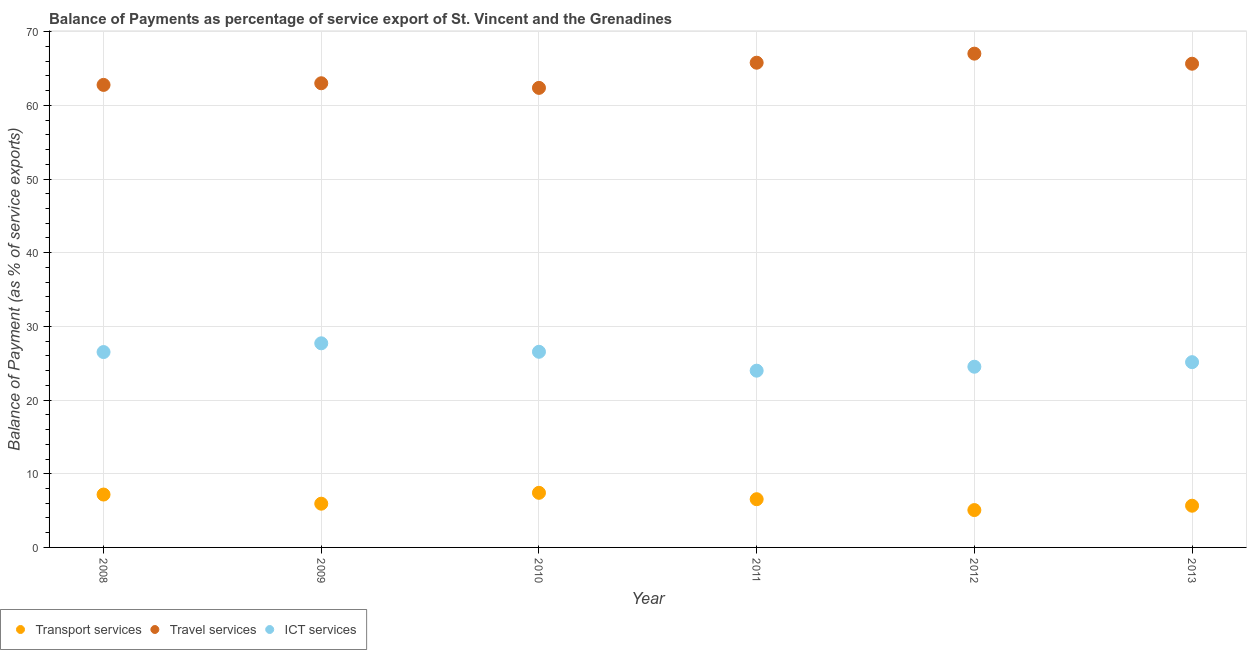What is the balance of payment of ict services in 2011?
Provide a short and direct response. 23.99. Across all years, what is the maximum balance of payment of transport services?
Your answer should be very brief. 7.41. Across all years, what is the minimum balance of payment of ict services?
Ensure brevity in your answer.  23.99. In which year was the balance of payment of transport services minimum?
Make the answer very short. 2012. What is the total balance of payment of travel services in the graph?
Offer a terse response. 386.58. What is the difference between the balance of payment of transport services in 2012 and that in 2013?
Your answer should be very brief. -0.59. What is the difference between the balance of payment of transport services in 2010 and the balance of payment of ict services in 2009?
Keep it short and to the point. -20.29. What is the average balance of payment of ict services per year?
Your answer should be compact. 25.74. In the year 2011, what is the difference between the balance of payment of transport services and balance of payment of ict services?
Give a very brief answer. -17.44. What is the ratio of the balance of payment of ict services in 2009 to that in 2013?
Provide a succinct answer. 1.1. Is the difference between the balance of payment of ict services in 2008 and 2010 greater than the difference between the balance of payment of transport services in 2008 and 2010?
Ensure brevity in your answer.  Yes. What is the difference between the highest and the second highest balance of payment of ict services?
Offer a terse response. 1.15. What is the difference between the highest and the lowest balance of payment of travel services?
Provide a succinct answer. 4.65. In how many years, is the balance of payment of travel services greater than the average balance of payment of travel services taken over all years?
Keep it short and to the point. 3. Is it the case that in every year, the sum of the balance of payment of transport services and balance of payment of travel services is greater than the balance of payment of ict services?
Your answer should be compact. Yes. Does the balance of payment of travel services monotonically increase over the years?
Offer a terse response. No. Is the balance of payment of ict services strictly greater than the balance of payment of transport services over the years?
Give a very brief answer. Yes. Is the balance of payment of travel services strictly less than the balance of payment of transport services over the years?
Ensure brevity in your answer.  No. How many years are there in the graph?
Your answer should be compact. 6. Where does the legend appear in the graph?
Your response must be concise. Bottom left. How many legend labels are there?
Give a very brief answer. 3. How are the legend labels stacked?
Make the answer very short. Horizontal. What is the title of the graph?
Your answer should be very brief. Balance of Payments as percentage of service export of St. Vincent and the Grenadines. Does "Ages 0-14" appear as one of the legend labels in the graph?
Make the answer very short. No. What is the label or title of the X-axis?
Give a very brief answer. Year. What is the label or title of the Y-axis?
Make the answer very short. Balance of Payment (as % of service exports). What is the Balance of Payment (as % of service exports) of Transport services in 2008?
Your answer should be very brief. 7.18. What is the Balance of Payment (as % of service exports) in Travel services in 2008?
Your answer should be compact. 62.77. What is the Balance of Payment (as % of service exports) in ICT services in 2008?
Give a very brief answer. 26.52. What is the Balance of Payment (as % of service exports) in Transport services in 2009?
Provide a succinct answer. 5.94. What is the Balance of Payment (as % of service exports) in Travel services in 2009?
Your answer should be compact. 63. What is the Balance of Payment (as % of service exports) of ICT services in 2009?
Provide a succinct answer. 27.7. What is the Balance of Payment (as % of service exports) in Transport services in 2010?
Make the answer very short. 7.41. What is the Balance of Payment (as % of service exports) of Travel services in 2010?
Your answer should be compact. 62.37. What is the Balance of Payment (as % of service exports) in ICT services in 2010?
Your answer should be compact. 26.55. What is the Balance of Payment (as % of service exports) of Transport services in 2011?
Offer a very short reply. 6.54. What is the Balance of Payment (as % of service exports) of Travel services in 2011?
Give a very brief answer. 65.78. What is the Balance of Payment (as % of service exports) of ICT services in 2011?
Provide a succinct answer. 23.99. What is the Balance of Payment (as % of service exports) of Transport services in 2012?
Your answer should be very brief. 5.07. What is the Balance of Payment (as % of service exports) of Travel services in 2012?
Your answer should be very brief. 67.01. What is the Balance of Payment (as % of service exports) in ICT services in 2012?
Offer a terse response. 24.52. What is the Balance of Payment (as % of service exports) of Transport services in 2013?
Provide a short and direct response. 5.66. What is the Balance of Payment (as % of service exports) in Travel services in 2013?
Offer a very short reply. 65.65. What is the Balance of Payment (as % of service exports) in ICT services in 2013?
Provide a succinct answer. 25.14. Across all years, what is the maximum Balance of Payment (as % of service exports) in Transport services?
Keep it short and to the point. 7.41. Across all years, what is the maximum Balance of Payment (as % of service exports) of Travel services?
Ensure brevity in your answer.  67.01. Across all years, what is the maximum Balance of Payment (as % of service exports) in ICT services?
Provide a succinct answer. 27.7. Across all years, what is the minimum Balance of Payment (as % of service exports) in Transport services?
Your answer should be very brief. 5.07. Across all years, what is the minimum Balance of Payment (as % of service exports) in Travel services?
Offer a terse response. 62.37. Across all years, what is the minimum Balance of Payment (as % of service exports) in ICT services?
Your response must be concise. 23.99. What is the total Balance of Payment (as % of service exports) in Transport services in the graph?
Offer a very short reply. 37.8. What is the total Balance of Payment (as % of service exports) of Travel services in the graph?
Offer a terse response. 386.58. What is the total Balance of Payment (as % of service exports) of ICT services in the graph?
Your response must be concise. 154.42. What is the difference between the Balance of Payment (as % of service exports) in Transport services in 2008 and that in 2009?
Your response must be concise. 1.24. What is the difference between the Balance of Payment (as % of service exports) of Travel services in 2008 and that in 2009?
Your answer should be compact. -0.22. What is the difference between the Balance of Payment (as % of service exports) in ICT services in 2008 and that in 2009?
Provide a short and direct response. -1.19. What is the difference between the Balance of Payment (as % of service exports) in Transport services in 2008 and that in 2010?
Make the answer very short. -0.23. What is the difference between the Balance of Payment (as % of service exports) of Travel services in 2008 and that in 2010?
Ensure brevity in your answer.  0.4. What is the difference between the Balance of Payment (as % of service exports) in ICT services in 2008 and that in 2010?
Provide a succinct answer. -0.04. What is the difference between the Balance of Payment (as % of service exports) in Transport services in 2008 and that in 2011?
Provide a short and direct response. 0.63. What is the difference between the Balance of Payment (as % of service exports) of Travel services in 2008 and that in 2011?
Your answer should be compact. -3.01. What is the difference between the Balance of Payment (as % of service exports) in ICT services in 2008 and that in 2011?
Give a very brief answer. 2.53. What is the difference between the Balance of Payment (as % of service exports) of Transport services in 2008 and that in 2012?
Make the answer very short. 2.11. What is the difference between the Balance of Payment (as % of service exports) in Travel services in 2008 and that in 2012?
Your response must be concise. -4.24. What is the difference between the Balance of Payment (as % of service exports) of ICT services in 2008 and that in 2012?
Provide a succinct answer. 1.99. What is the difference between the Balance of Payment (as % of service exports) in Transport services in 2008 and that in 2013?
Offer a terse response. 1.52. What is the difference between the Balance of Payment (as % of service exports) of Travel services in 2008 and that in 2013?
Ensure brevity in your answer.  -2.87. What is the difference between the Balance of Payment (as % of service exports) of ICT services in 2008 and that in 2013?
Ensure brevity in your answer.  1.37. What is the difference between the Balance of Payment (as % of service exports) of Transport services in 2009 and that in 2010?
Your response must be concise. -1.48. What is the difference between the Balance of Payment (as % of service exports) of Travel services in 2009 and that in 2010?
Your answer should be very brief. 0.63. What is the difference between the Balance of Payment (as % of service exports) in ICT services in 2009 and that in 2010?
Make the answer very short. 1.15. What is the difference between the Balance of Payment (as % of service exports) of Transport services in 2009 and that in 2011?
Your response must be concise. -0.61. What is the difference between the Balance of Payment (as % of service exports) of Travel services in 2009 and that in 2011?
Provide a succinct answer. -2.79. What is the difference between the Balance of Payment (as % of service exports) in ICT services in 2009 and that in 2011?
Provide a succinct answer. 3.71. What is the difference between the Balance of Payment (as % of service exports) of Transport services in 2009 and that in 2012?
Provide a succinct answer. 0.86. What is the difference between the Balance of Payment (as % of service exports) in Travel services in 2009 and that in 2012?
Keep it short and to the point. -4.02. What is the difference between the Balance of Payment (as % of service exports) of ICT services in 2009 and that in 2012?
Your answer should be very brief. 3.18. What is the difference between the Balance of Payment (as % of service exports) of Transport services in 2009 and that in 2013?
Offer a terse response. 0.27. What is the difference between the Balance of Payment (as % of service exports) in Travel services in 2009 and that in 2013?
Keep it short and to the point. -2.65. What is the difference between the Balance of Payment (as % of service exports) in ICT services in 2009 and that in 2013?
Keep it short and to the point. 2.56. What is the difference between the Balance of Payment (as % of service exports) of Transport services in 2010 and that in 2011?
Provide a succinct answer. 0.87. What is the difference between the Balance of Payment (as % of service exports) of Travel services in 2010 and that in 2011?
Give a very brief answer. -3.42. What is the difference between the Balance of Payment (as % of service exports) of ICT services in 2010 and that in 2011?
Keep it short and to the point. 2.56. What is the difference between the Balance of Payment (as % of service exports) in Transport services in 2010 and that in 2012?
Offer a terse response. 2.34. What is the difference between the Balance of Payment (as % of service exports) of Travel services in 2010 and that in 2012?
Offer a very short reply. -4.65. What is the difference between the Balance of Payment (as % of service exports) of ICT services in 2010 and that in 2012?
Give a very brief answer. 2.03. What is the difference between the Balance of Payment (as % of service exports) in Travel services in 2010 and that in 2013?
Ensure brevity in your answer.  -3.28. What is the difference between the Balance of Payment (as % of service exports) in ICT services in 2010 and that in 2013?
Keep it short and to the point. 1.41. What is the difference between the Balance of Payment (as % of service exports) of Transport services in 2011 and that in 2012?
Keep it short and to the point. 1.47. What is the difference between the Balance of Payment (as % of service exports) in Travel services in 2011 and that in 2012?
Make the answer very short. -1.23. What is the difference between the Balance of Payment (as % of service exports) of ICT services in 2011 and that in 2012?
Offer a very short reply. -0.54. What is the difference between the Balance of Payment (as % of service exports) of Transport services in 2011 and that in 2013?
Ensure brevity in your answer.  0.88. What is the difference between the Balance of Payment (as % of service exports) of Travel services in 2011 and that in 2013?
Keep it short and to the point. 0.14. What is the difference between the Balance of Payment (as % of service exports) of ICT services in 2011 and that in 2013?
Offer a terse response. -1.16. What is the difference between the Balance of Payment (as % of service exports) of Transport services in 2012 and that in 2013?
Your answer should be very brief. -0.59. What is the difference between the Balance of Payment (as % of service exports) in Travel services in 2012 and that in 2013?
Ensure brevity in your answer.  1.37. What is the difference between the Balance of Payment (as % of service exports) of ICT services in 2012 and that in 2013?
Make the answer very short. -0.62. What is the difference between the Balance of Payment (as % of service exports) of Transport services in 2008 and the Balance of Payment (as % of service exports) of Travel services in 2009?
Keep it short and to the point. -55.82. What is the difference between the Balance of Payment (as % of service exports) in Transport services in 2008 and the Balance of Payment (as % of service exports) in ICT services in 2009?
Your answer should be compact. -20.53. What is the difference between the Balance of Payment (as % of service exports) in Travel services in 2008 and the Balance of Payment (as % of service exports) in ICT services in 2009?
Your answer should be very brief. 35.07. What is the difference between the Balance of Payment (as % of service exports) of Transport services in 2008 and the Balance of Payment (as % of service exports) of Travel services in 2010?
Your response must be concise. -55.19. What is the difference between the Balance of Payment (as % of service exports) in Transport services in 2008 and the Balance of Payment (as % of service exports) in ICT services in 2010?
Your response must be concise. -19.37. What is the difference between the Balance of Payment (as % of service exports) in Travel services in 2008 and the Balance of Payment (as % of service exports) in ICT services in 2010?
Make the answer very short. 36.22. What is the difference between the Balance of Payment (as % of service exports) of Transport services in 2008 and the Balance of Payment (as % of service exports) of Travel services in 2011?
Ensure brevity in your answer.  -58.61. What is the difference between the Balance of Payment (as % of service exports) of Transport services in 2008 and the Balance of Payment (as % of service exports) of ICT services in 2011?
Offer a very short reply. -16.81. What is the difference between the Balance of Payment (as % of service exports) of Travel services in 2008 and the Balance of Payment (as % of service exports) of ICT services in 2011?
Provide a succinct answer. 38.78. What is the difference between the Balance of Payment (as % of service exports) in Transport services in 2008 and the Balance of Payment (as % of service exports) in Travel services in 2012?
Provide a succinct answer. -59.84. What is the difference between the Balance of Payment (as % of service exports) of Transport services in 2008 and the Balance of Payment (as % of service exports) of ICT services in 2012?
Offer a terse response. -17.35. What is the difference between the Balance of Payment (as % of service exports) of Travel services in 2008 and the Balance of Payment (as % of service exports) of ICT services in 2012?
Your answer should be very brief. 38.25. What is the difference between the Balance of Payment (as % of service exports) of Transport services in 2008 and the Balance of Payment (as % of service exports) of Travel services in 2013?
Provide a succinct answer. -58.47. What is the difference between the Balance of Payment (as % of service exports) of Transport services in 2008 and the Balance of Payment (as % of service exports) of ICT services in 2013?
Make the answer very short. -17.97. What is the difference between the Balance of Payment (as % of service exports) of Travel services in 2008 and the Balance of Payment (as % of service exports) of ICT services in 2013?
Ensure brevity in your answer.  37.63. What is the difference between the Balance of Payment (as % of service exports) in Transport services in 2009 and the Balance of Payment (as % of service exports) in Travel services in 2010?
Provide a short and direct response. -56.43. What is the difference between the Balance of Payment (as % of service exports) in Transport services in 2009 and the Balance of Payment (as % of service exports) in ICT services in 2010?
Provide a short and direct response. -20.62. What is the difference between the Balance of Payment (as % of service exports) in Travel services in 2009 and the Balance of Payment (as % of service exports) in ICT services in 2010?
Make the answer very short. 36.45. What is the difference between the Balance of Payment (as % of service exports) in Transport services in 2009 and the Balance of Payment (as % of service exports) in Travel services in 2011?
Your answer should be compact. -59.85. What is the difference between the Balance of Payment (as % of service exports) in Transport services in 2009 and the Balance of Payment (as % of service exports) in ICT services in 2011?
Provide a succinct answer. -18.05. What is the difference between the Balance of Payment (as % of service exports) of Travel services in 2009 and the Balance of Payment (as % of service exports) of ICT services in 2011?
Offer a terse response. 39.01. What is the difference between the Balance of Payment (as % of service exports) of Transport services in 2009 and the Balance of Payment (as % of service exports) of Travel services in 2012?
Provide a short and direct response. -61.08. What is the difference between the Balance of Payment (as % of service exports) in Transport services in 2009 and the Balance of Payment (as % of service exports) in ICT services in 2012?
Give a very brief answer. -18.59. What is the difference between the Balance of Payment (as % of service exports) in Travel services in 2009 and the Balance of Payment (as % of service exports) in ICT services in 2012?
Ensure brevity in your answer.  38.47. What is the difference between the Balance of Payment (as % of service exports) of Transport services in 2009 and the Balance of Payment (as % of service exports) of Travel services in 2013?
Ensure brevity in your answer.  -59.71. What is the difference between the Balance of Payment (as % of service exports) of Transport services in 2009 and the Balance of Payment (as % of service exports) of ICT services in 2013?
Offer a very short reply. -19.21. What is the difference between the Balance of Payment (as % of service exports) in Travel services in 2009 and the Balance of Payment (as % of service exports) in ICT services in 2013?
Your response must be concise. 37.85. What is the difference between the Balance of Payment (as % of service exports) in Transport services in 2010 and the Balance of Payment (as % of service exports) in Travel services in 2011?
Ensure brevity in your answer.  -58.37. What is the difference between the Balance of Payment (as % of service exports) in Transport services in 2010 and the Balance of Payment (as % of service exports) in ICT services in 2011?
Provide a succinct answer. -16.58. What is the difference between the Balance of Payment (as % of service exports) in Travel services in 2010 and the Balance of Payment (as % of service exports) in ICT services in 2011?
Your response must be concise. 38.38. What is the difference between the Balance of Payment (as % of service exports) in Transport services in 2010 and the Balance of Payment (as % of service exports) in Travel services in 2012?
Ensure brevity in your answer.  -59.6. What is the difference between the Balance of Payment (as % of service exports) of Transport services in 2010 and the Balance of Payment (as % of service exports) of ICT services in 2012?
Offer a terse response. -17.11. What is the difference between the Balance of Payment (as % of service exports) of Travel services in 2010 and the Balance of Payment (as % of service exports) of ICT services in 2012?
Your answer should be very brief. 37.84. What is the difference between the Balance of Payment (as % of service exports) of Transport services in 2010 and the Balance of Payment (as % of service exports) of Travel services in 2013?
Offer a terse response. -58.24. What is the difference between the Balance of Payment (as % of service exports) of Transport services in 2010 and the Balance of Payment (as % of service exports) of ICT services in 2013?
Ensure brevity in your answer.  -17.73. What is the difference between the Balance of Payment (as % of service exports) in Travel services in 2010 and the Balance of Payment (as % of service exports) in ICT services in 2013?
Make the answer very short. 37.23. What is the difference between the Balance of Payment (as % of service exports) in Transport services in 2011 and the Balance of Payment (as % of service exports) in Travel services in 2012?
Offer a very short reply. -60.47. What is the difference between the Balance of Payment (as % of service exports) in Transport services in 2011 and the Balance of Payment (as % of service exports) in ICT services in 2012?
Make the answer very short. -17.98. What is the difference between the Balance of Payment (as % of service exports) in Travel services in 2011 and the Balance of Payment (as % of service exports) in ICT services in 2012?
Your answer should be very brief. 41.26. What is the difference between the Balance of Payment (as % of service exports) of Transport services in 2011 and the Balance of Payment (as % of service exports) of Travel services in 2013?
Make the answer very short. -59.1. What is the difference between the Balance of Payment (as % of service exports) in Transport services in 2011 and the Balance of Payment (as % of service exports) in ICT services in 2013?
Make the answer very short. -18.6. What is the difference between the Balance of Payment (as % of service exports) of Travel services in 2011 and the Balance of Payment (as % of service exports) of ICT services in 2013?
Make the answer very short. 40.64. What is the difference between the Balance of Payment (as % of service exports) in Transport services in 2012 and the Balance of Payment (as % of service exports) in Travel services in 2013?
Make the answer very short. -60.58. What is the difference between the Balance of Payment (as % of service exports) in Transport services in 2012 and the Balance of Payment (as % of service exports) in ICT services in 2013?
Your answer should be compact. -20.07. What is the difference between the Balance of Payment (as % of service exports) of Travel services in 2012 and the Balance of Payment (as % of service exports) of ICT services in 2013?
Ensure brevity in your answer.  41.87. What is the average Balance of Payment (as % of service exports) in Transport services per year?
Keep it short and to the point. 6.3. What is the average Balance of Payment (as % of service exports) in Travel services per year?
Provide a short and direct response. 64.43. What is the average Balance of Payment (as % of service exports) of ICT services per year?
Provide a short and direct response. 25.74. In the year 2008, what is the difference between the Balance of Payment (as % of service exports) in Transport services and Balance of Payment (as % of service exports) in Travel services?
Your answer should be very brief. -55.6. In the year 2008, what is the difference between the Balance of Payment (as % of service exports) of Transport services and Balance of Payment (as % of service exports) of ICT services?
Make the answer very short. -19.34. In the year 2008, what is the difference between the Balance of Payment (as % of service exports) of Travel services and Balance of Payment (as % of service exports) of ICT services?
Offer a terse response. 36.26. In the year 2009, what is the difference between the Balance of Payment (as % of service exports) of Transport services and Balance of Payment (as % of service exports) of Travel services?
Ensure brevity in your answer.  -57.06. In the year 2009, what is the difference between the Balance of Payment (as % of service exports) in Transport services and Balance of Payment (as % of service exports) in ICT services?
Give a very brief answer. -21.77. In the year 2009, what is the difference between the Balance of Payment (as % of service exports) of Travel services and Balance of Payment (as % of service exports) of ICT services?
Provide a short and direct response. 35.29. In the year 2010, what is the difference between the Balance of Payment (as % of service exports) of Transport services and Balance of Payment (as % of service exports) of Travel services?
Make the answer very short. -54.96. In the year 2010, what is the difference between the Balance of Payment (as % of service exports) in Transport services and Balance of Payment (as % of service exports) in ICT services?
Give a very brief answer. -19.14. In the year 2010, what is the difference between the Balance of Payment (as % of service exports) of Travel services and Balance of Payment (as % of service exports) of ICT services?
Your response must be concise. 35.82. In the year 2011, what is the difference between the Balance of Payment (as % of service exports) in Transport services and Balance of Payment (as % of service exports) in Travel services?
Your answer should be compact. -59.24. In the year 2011, what is the difference between the Balance of Payment (as % of service exports) of Transport services and Balance of Payment (as % of service exports) of ICT services?
Make the answer very short. -17.44. In the year 2011, what is the difference between the Balance of Payment (as % of service exports) in Travel services and Balance of Payment (as % of service exports) in ICT services?
Ensure brevity in your answer.  41.8. In the year 2012, what is the difference between the Balance of Payment (as % of service exports) in Transport services and Balance of Payment (as % of service exports) in Travel services?
Provide a short and direct response. -61.94. In the year 2012, what is the difference between the Balance of Payment (as % of service exports) of Transport services and Balance of Payment (as % of service exports) of ICT services?
Your response must be concise. -19.45. In the year 2012, what is the difference between the Balance of Payment (as % of service exports) in Travel services and Balance of Payment (as % of service exports) in ICT services?
Your answer should be very brief. 42.49. In the year 2013, what is the difference between the Balance of Payment (as % of service exports) in Transport services and Balance of Payment (as % of service exports) in Travel services?
Keep it short and to the point. -59.99. In the year 2013, what is the difference between the Balance of Payment (as % of service exports) of Transport services and Balance of Payment (as % of service exports) of ICT services?
Offer a very short reply. -19.48. In the year 2013, what is the difference between the Balance of Payment (as % of service exports) in Travel services and Balance of Payment (as % of service exports) in ICT services?
Your response must be concise. 40.5. What is the ratio of the Balance of Payment (as % of service exports) of Transport services in 2008 to that in 2009?
Provide a short and direct response. 1.21. What is the ratio of the Balance of Payment (as % of service exports) in Travel services in 2008 to that in 2009?
Ensure brevity in your answer.  1. What is the ratio of the Balance of Payment (as % of service exports) in ICT services in 2008 to that in 2009?
Make the answer very short. 0.96. What is the ratio of the Balance of Payment (as % of service exports) of Transport services in 2008 to that in 2010?
Your answer should be compact. 0.97. What is the ratio of the Balance of Payment (as % of service exports) of ICT services in 2008 to that in 2010?
Make the answer very short. 1. What is the ratio of the Balance of Payment (as % of service exports) in Transport services in 2008 to that in 2011?
Your answer should be compact. 1.1. What is the ratio of the Balance of Payment (as % of service exports) of Travel services in 2008 to that in 2011?
Make the answer very short. 0.95. What is the ratio of the Balance of Payment (as % of service exports) in ICT services in 2008 to that in 2011?
Ensure brevity in your answer.  1.11. What is the ratio of the Balance of Payment (as % of service exports) of Transport services in 2008 to that in 2012?
Ensure brevity in your answer.  1.42. What is the ratio of the Balance of Payment (as % of service exports) of Travel services in 2008 to that in 2012?
Give a very brief answer. 0.94. What is the ratio of the Balance of Payment (as % of service exports) of ICT services in 2008 to that in 2012?
Make the answer very short. 1.08. What is the ratio of the Balance of Payment (as % of service exports) in Transport services in 2008 to that in 2013?
Offer a very short reply. 1.27. What is the ratio of the Balance of Payment (as % of service exports) of Travel services in 2008 to that in 2013?
Offer a terse response. 0.96. What is the ratio of the Balance of Payment (as % of service exports) in ICT services in 2008 to that in 2013?
Offer a very short reply. 1.05. What is the ratio of the Balance of Payment (as % of service exports) in Transport services in 2009 to that in 2010?
Provide a short and direct response. 0.8. What is the ratio of the Balance of Payment (as % of service exports) of ICT services in 2009 to that in 2010?
Your response must be concise. 1.04. What is the ratio of the Balance of Payment (as % of service exports) in Transport services in 2009 to that in 2011?
Ensure brevity in your answer.  0.91. What is the ratio of the Balance of Payment (as % of service exports) in Travel services in 2009 to that in 2011?
Ensure brevity in your answer.  0.96. What is the ratio of the Balance of Payment (as % of service exports) in ICT services in 2009 to that in 2011?
Ensure brevity in your answer.  1.15. What is the ratio of the Balance of Payment (as % of service exports) of Transport services in 2009 to that in 2012?
Ensure brevity in your answer.  1.17. What is the ratio of the Balance of Payment (as % of service exports) in ICT services in 2009 to that in 2012?
Provide a succinct answer. 1.13. What is the ratio of the Balance of Payment (as % of service exports) in Transport services in 2009 to that in 2013?
Offer a very short reply. 1.05. What is the ratio of the Balance of Payment (as % of service exports) of Travel services in 2009 to that in 2013?
Give a very brief answer. 0.96. What is the ratio of the Balance of Payment (as % of service exports) of ICT services in 2009 to that in 2013?
Your answer should be very brief. 1.1. What is the ratio of the Balance of Payment (as % of service exports) in Transport services in 2010 to that in 2011?
Offer a very short reply. 1.13. What is the ratio of the Balance of Payment (as % of service exports) in Travel services in 2010 to that in 2011?
Your answer should be compact. 0.95. What is the ratio of the Balance of Payment (as % of service exports) of ICT services in 2010 to that in 2011?
Ensure brevity in your answer.  1.11. What is the ratio of the Balance of Payment (as % of service exports) in Transport services in 2010 to that in 2012?
Provide a succinct answer. 1.46. What is the ratio of the Balance of Payment (as % of service exports) of Travel services in 2010 to that in 2012?
Your answer should be very brief. 0.93. What is the ratio of the Balance of Payment (as % of service exports) in ICT services in 2010 to that in 2012?
Keep it short and to the point. 1.08. What is the ratio of the Balance of Payment (as % of service exports) of Transport services in 2010 to that in 2013?
Your answer should be very brief. 1.31. What is the ratio of the Balance of Payment (as % of service exports) in Travel services in 2010 to that in 2013?
Your answer should be compact. 0.95. What is the ratio of the Balance of Payment (as % of service exports) in ICT services in 2010 to that in 2013?
Ensure brevity in your answer.  1.06. What is the ratio of the Balance of Payment (as % of service exports) of Transport services in 2011 to that in 2012?
Offer a terse response. 1.29. What is the ratio of the Balance of Payment (as % of service exports) of Travel services in 2011 to that in 2012?
Give a very brief answer. 0.98. What is the ratio of the Balance of Payment (as % of service exports) in ICT services in 2011 to that in 2012?
Provide a succinct answer. 0.98. What is the ratio of the Balance of Payment (as % of service exports) of Transport services in 2011 to that in 2013?
Provide a succinct answer. 1.16. What is the ratio of the Balance of Payment (as % of service exports) in Travel services in 2011 to that in 2013?
Ensure brevity in your answer.  1. What is the ratio of the Balance of Payment (as % of service exports) of ICT services in 2011 to that in 2013?
Your answer should be compact. 0.95. What is the ratio of the Balance of Payment (as % of service exports) of Transport services in 2012 to that in 2013?
Your answer should be compact. 0.9. What is the ratio of the Balance of Payment (as % of service exports) in Travel services in 2012 to that in 2013?
Make the answer very short. 1.02. What is the ratio of the Balance of Payment (as % of service exports) of ICT services in 2012 to that in 2013?
Make the answer very short. 0.98. What is the difference between the highest and the second highest Balance of Payment (as % of service exports) of Transport services?
Give a very brief answer. 0.23. What is the difference between the highest and the second highest Balance of Payment (as % of service exports) of Travel services?
Your answer should be compact. 1.23. What is the difference between the highest and the second highest Balance of Payment (as % of service exports) in ICT services?
Your answer should be very brief. 1.15. What is the difference between the highest and the lowest Balance of Payment (as % of service exports) of Transport services?
Give a very brief answer. 2.34. What is the difference between the highest and the lowest Balance of Payment (as % of service exports) in Travel services?
Offer a very short reply. 4.65. What is the difference between the highest and the lowest Balance of Payment (as % of service exports) in ICT services?
Offer a terse response. 3.71. 